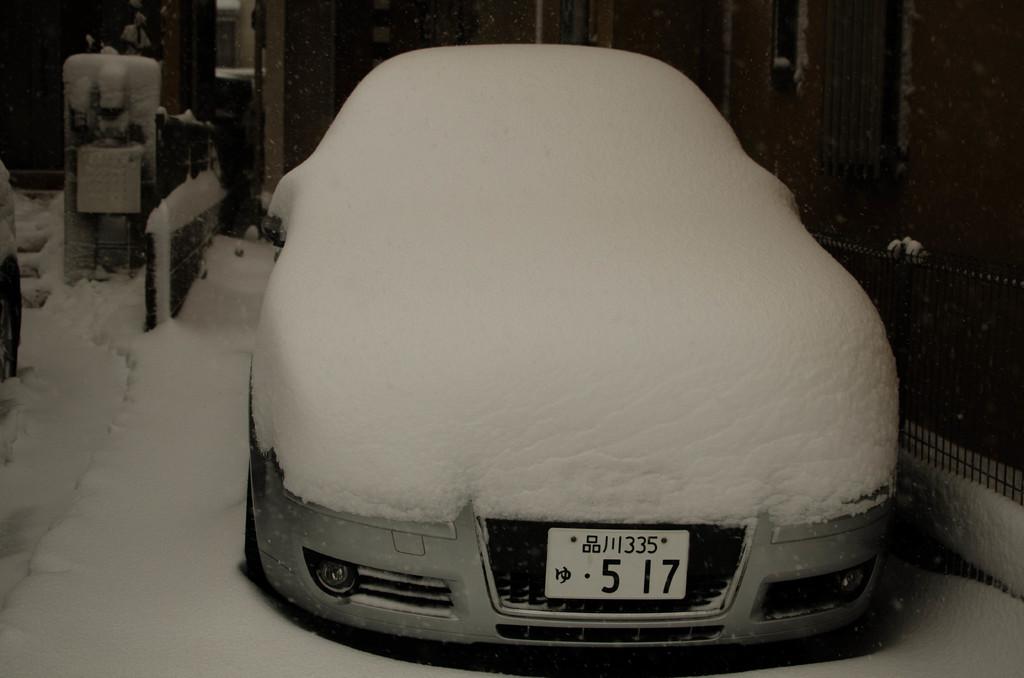What is the license plate number?
Your answer should be compact. 517. What number is displayed above the licence plate number?
Offer a terse response. 1335. 